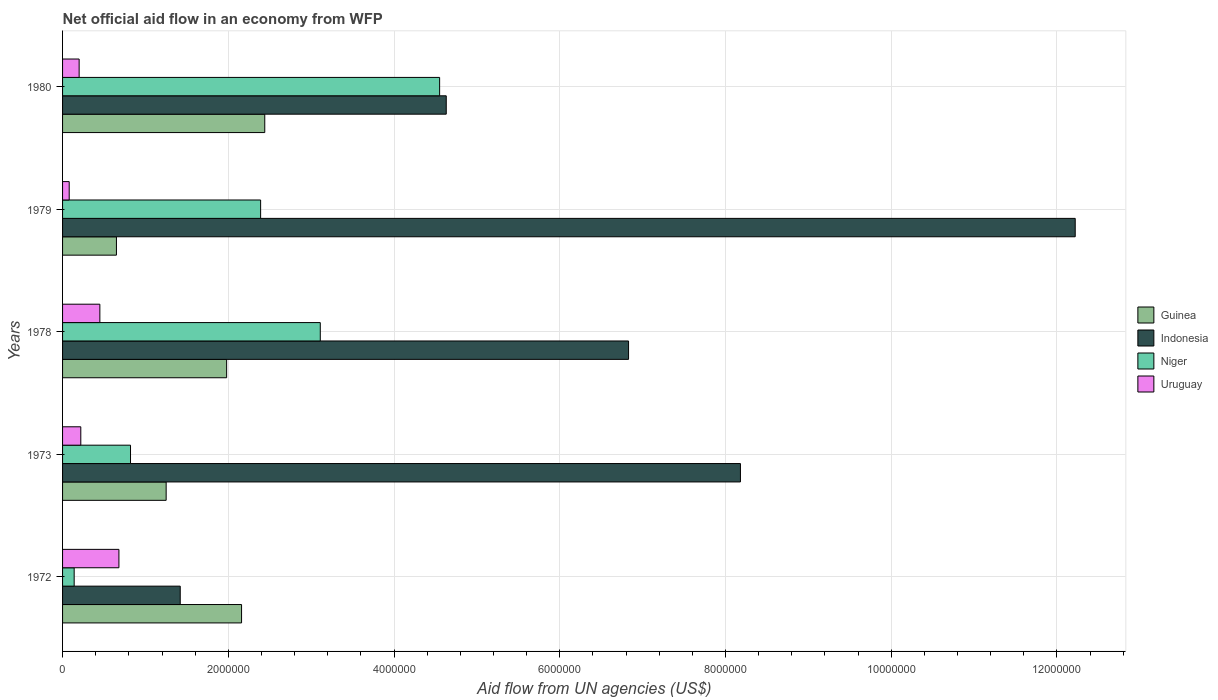How many different coloured bars are there?
Your response must be concise. 4. How many groups of bars are there?
Offer a very short reply. 5. Are the number of bars per tick equal to the number of legend labels?
Your response must be concise. Yes. Are the number of bars on each tick of the Y-axis equal?
Give a very brief answer. Yes. Across all years, what is the maximum net official aid flow in Uruguay?
Offer a very short reply. 6.80e+05. In which year was the net official aid flow in Indonesia maximum?
Make the answer very short. 1979. In which year was the net official aid flow in Uruguay minimum?
Provide a short and direct response. 1979. What is the total net official aid flow in Uruguay in the graph?
Offer a terse response. 1.63e+06. What is the difference between the net official aid flow in Indonesia in 1973 and the net official aid flow in Guinea in 1972?
Give a very brief answer. 6.02e+06. What is the average net official aid flow in Niger per year?
Your answer should be compact. 2.20e+06. In the year 1973, what is the difference between the net official aid flow in Niger and net official aid flow in Uruguay?
Ensure brevity in your answer.  6.00e+05. In how many years, is the net official aid flow in Niger greater than 400000 US$?
Give a very brief answer. 4. What is the ratio of the net official aid flow in Uruguay in 1972 to that in 1978?
Provide a short and direct response. 1.51. What does the 1st bar from the bottom in 1979 represents?
Offer a very short reply. Guinea. How many bars are there?
Provide a short and direct response. 20. What is the difference between two consecutive major ticks on the X-axis?
Provide a succinct answer. 2.00e+06. Are the values on the major ticks of X-axis written in scientific E-notation?
Your answer should be very brief. No. Does the graph contain any zero values?
Make the answer very short. No. How many legend labels are there?
Offer a very short reply. 4. What is the title of the graph?
Give a very brief answer. Net official aid flow in an economy from WFP. Does "Papua New Guinea" appear as one of the legend labels in the graph?
Your answer should be very brief. No. What is the label or title of the X-axis?
Your answer should be compact. Aid flow from UN agencies (US$). What is the label or title of the Y-axis?
Your answer should be very brief. Years. What is the Aid flow from UN agencies (US$) of Guinea in 1972?
Your response must be concise. 2.16e+06. What is the Aid flow from UN agencies (US$) in Indonesia in 1972?
Make the answer very short. 1.42e+06. What is the Aid flow from UN agencies (US$) of Niger in 1972?
Keep it short and to the point. 1.40e+05. What is the Aid flow from UN agencies (US$) in Uruguay in 1972?
Keep it short and to the point. 6.80e+05. What is the Aid flow from UN agencies (US$) of Guinea in 1973?
Give a very brief answer. 1.25e+06. What is the Aid flow from UN agencies (US$) of Indonesia in 1973?
Your answer should be very brief. 8.18e+06. What is the Aid flow from UN agencies (US$) in Niger in 1973?
Provide a succinct answer. 8.20e+05. What is the Aid flow from UN agencies (US$) of Guinea in 1978?
Your response must be concise. 1.98e+06. What is the Aid flow from UN agencies (US$) in Indonesia in 1978?
Give a very brief answer. 6.83e+06. What is the Aid flow from UN agencies (US$) of Niger in 1978?
Provide a short and direct response. 3.11e+06. What is the Aid flow from UN agencies (US$) of Uruguay in 1978?
Offer a terse response. 4.50e+05. What is the Aid flow from UN agencies (US$) of Guinea in 1979?
Keep it short and to the point. 6.50e+05. What is the Aid flow from UN agencies (US$) in Indonesia in 1979?
Your response must be concise. 1.22e+07. What is the Aid flow from UN agencies (US$) in Niger in 1979?
Make the answer very short. 2.39e+06. What is the Aid flow from UN agencies (US$) of Uruguay in 1979?
Offer a terse response. 8.00e+04. What is the Aid flow from UN agencies (US$) in Guinea in 1980?
Offer a terse response. 2.44e+06. What is the Aid flow from UN agencies (US$) in Indonesia in 1980?
Make the answer very short. 4.63e+06. What is the Aid flow from UN agencies (US$) in Niger in 1980?
Give a very brief answer. 4.55e+06. What is the Aid flow from UN agencies (US$) of Uruguay in 1980?
Keep it short and to the point. 2.00e+05. Across all years, what is the maximum Aid flow from UN agencies (US$) in Guinea?
Your response must be concise. 2.44e+06. Across all years, what is the maximum Aid flow from UN agencies (US$) in Indonesia?
Keep it short and to the point. 1.22e+07. Across all years, what is the maximum Aid flow from UN agencies (US$) in Niger?
Keep it short and to the point. 4.55e+06. Across all years, what is the maximum Aid flow from UN agencies (US$) in Uruguay?
Give a very brief answer. 6.80e+05. Across all years, what is the minimum Aid flow from UN agencies (US$) in Guinea?
Your answer should be very brief. 6.50e+05. Across all years, what is the minimum Aid flow from UN agencies (US$) of Indonesia?
Keep it short and to the point. 1.42e+06. Across all years, what is the minimum Aid flow from UN agencies (US$) in Niger?
Offer a terse response. 1.40e+05. What is the total Aid flow from UN agencies (US$) of Guinea in the graph?
Give a very brief answer. 8.48e+06. What is the total Aid flow from UN agencies (US$) in Indonesia in the graph?
Ensure brevity in your answer.  3.33e+07. What is the total Aid flow from UN agencies (US$) in Niger in the graph?
Make the answer very short. 1.10e+07. What is the total Aid flow from UN agencies (US$) of Uruguay in the graph?
Offer a terse response. 1.63e+06. What is the difference between the Aid flow from UN agencies (US$) of Guinea in 1972 and that in 1973?
Offer a very short reply. 9.10e+05. What is the difference between the Aid flow from UN agencies (US$) in Indonesia in 1972 and that in 1973?
Provide a short and direct response. -6.76e+06. What is the difference between the Aid flow from UN agencies (US$) in Niger in 1972 and that in 1973?
Keep it short and to the point. -6.80e+05. What is the difference between the Aid flow from UN agencies (US$) of Indonesia in 1972 and that in 1978?
Offer a very short reply. -5.41e+06. What is the difference between the Aid flow from UN agencies (US$) in Niger in 1972 and that in 1978?
Keep it short and to the point. -2.97e+06. What is the difference between the Aid flow from UN agencies (US$) of Guinea in 1972 and that in 1979?
Give a very brief answer. 1.51e+06. What is the difference between the Aid flow from UN agencies (US$) in Indonesia in 1972 and that in 1979?
Your response must be concise. -1.08e+07. What is the difference between the Aid flow from UN agencies (US$) of Niger in 1972 and that in 1979?
Provide a succinct answer. -2.25e+06. What is the difference between the Aid flow from UN agencies (US$) in Uruguay in 1972 and that in 1979?
Make the answer very short. 6.00e+05. What is the difference between the Aid flow from UN agencies (US$) of Guinea in 1972 and that in 1980?
Your answer should be compact. -2.80e+05. What is the difference between the Aid flow from UN agencies (US$) of Indonesia in 1972 and that in 1980?
Keep it short and to the point. -3.21e+06. What is the difference between the Aid flow from UN agencies (US$) in Niger in 1972 and that in 1980?
Your answer should be compact. -4.41e+06. What is the difference between the Aid flow from UN agencies (US$) in Guinea in 1973 and that in 1978?
Keep it short and to the point. -7.30e+05. What is the difference between the Aid flow from UN agencies (US$) of Indonesia in 1973 and that in 1978?
Make the answer very short. 1.35e+06. What is the difference between the Aid flow from UN agencies (US$) in Niger in 1973 and that in 1978?
Provide a short and direct response. -2.29e+06. What is the difference between the Aid flow from UN agencies (US$) of Uruguay in 1973 and that in 1978?
Give a very brief answer. -2.30e+05. What is the difference between the Aid flow from UN agencies (US$) of Guinea in 1973 and that in 1979?
Keep it short and to the point. 6.00e+05. What is the difference between the Aid flow from UN agencies (US$) of Indonesia in 1973 and that in 1979?
Provide a short and direct response. -4.04e+06. What is the difference between the Aid flow from UN agencies (US$) in Niger in 1973 and that in 1979?
Make the answer very short. -1.57e+06. What is the difference between the Aid flow from UN agencies (US$) of Guinea in 1973 and that in 1980?
Offer a terse response. -1.19e+06. What is the difference between the Aid flow from UN agencies (US$) in Indonesia in 1973 and that in 1980?
Your response must be concise. 3.55e+06. What is the difference between the Aid flow from UN agencies (US$) in Niger in 1973 and that in 1980?
Make the answer very short. -3.73e+06. What is the difference between the Aid flow from UN agencies (US$) in Guinea in 1978 and that in 1979?
Provide a short and direct response. 1.33e+06. What is the difference between the Aid flow from UN agencies (US$) of Indonesia in 1978 and that in 1979?
Make the answer very short. -5.39e+06. What is the difference between the Aid flow from UN agencies (US$) in Niger in 1978 and that in 1979?
Provide a short and direct response. 7.20e+05. What is the difference between the Aid flow from UN agencies (US$) of Uruguay in 1978 and that in 1979?
Your answer should be very brief. 3.70e+05. What is the difference between the Aid flow from UN agencies (US$) in Guinea in 1978 and that in 1980?
Keep it short and to the point. -4.60e+05. What is the difference between the Aid flow from UN agencies (US$) of Indonesia in 1978 and that in 1980?
Give a very brief answer. 2.20e+06. What is the difference between the Aid flow from UN agencies (US$) of Niger in 1978 and that in 1980?
Keep it short and to the point. -1.44e+06. What is the difference between the Aid flow from UN agencies (US$) in Uruguay in 1978 and that in 1980?
Keep it short and to the point. 2.50e+05. What is the difference between the Aid flow from UN agencies (US$) of Guinea in 1979 and that in 1980?
Your response must be concise. -1.79e+06. What is the difference between the Aid flow from UN agencies (US$) in Indonesia in 1979 and that in 1980?
Offer a very short reply. 7.59e+06. What is the difference between the Aid flow from UN agencies (US$) of Niger in 1979 and that in 1980?
Your answer should be compact. -2.16e+06. What is the difference between the Aid flow from UN agencies (US$) of Guinea in 1972 and the Aid flow from UN agencies (US$) of Indonesia in 1973?
Offer a terse response. -6.02e+06. What is the difference between the Aid flow from UN agencies (US$) of Guinea in 1972 and the Aid flow from UN agencies (US$) of Niger in 1973?
Make the answer very short. 1.34e+06. What is the difference between the Aid flow from UN agencies (US$) in Guinea in 1972 and the Aid flow from UN agencies (US$) in Uruguay in 1973?
Provide a short and direct response. 1.94e+06. What is the difference between the Aid flow from UN agencies (US$) of Indonesia in 1972 and the Aid flow from UN agencies (US$) of Niger in 1973?
Your answer should be compact. 6.00e+05. What is the difference between the Aid flow from UN agencies (US$) in Indonesia in 1972 and the Aid flow from UN agencies (US$) in Uruguay in 1973?
Give a very brief answer. 1.20e+06. What is the difference between the Aid flow from UN agencies (US$) in Niger in 1972 and the Aid flow from UN agencies (US$) in Uruguay in 1973?
Your answer should be very brief. -8.00e+04. What is the difference between the Aid flow from UN agencies (US$) in Guinea in 1972 and the Aid flow from UN agencies (US$) in Indonesia in 1978?
Provide a succinct answer. -4.67e+06. What is the difference between the Aid flow from UN agencies (US$) in Guinea in 1972 and the Aid flow from UN agencies (US$) in Niger in 1978?
Provide a succinct answer. -9.50e+05. What is the difference between the Aid flow from UN agencies (US$) of Guinea in 1972 and the Aid flow from UN agencies (US$) of Uruguay in 1978?
Offer a very short reply. 1.71e+06. What is the difference between the Aid flow from UN agencies (US$) of Indonesia in 1972 and the Aid flow from UN agencies (US$) of Niger in 1978?
Offer a very short reply. -1.69e+06. What is the difference between the Aid flow from UN agencies (US$) in Indonesia in 1972 and the Aid flow from UN agencies (US$) in Uruguay in 1978?
Provide a succinct answer. 9.70e+05. What is the difference between the Aid flow from UN agencies (US$) in Niger in 1972 and the Aid flow from UN agencies (US$) in Uruguay in 1978?
Provide a succinct answer. -3.10e+05. What is the difference between the Aid flow from UN agencies (US$) in Guinea in 1972 and the Aid flow from UN agencies (US$) in Indonesia in 1979?
Make the answer very short. -1.01e+07. What is the difference between the Aid flow from UN agencies (US$) in Guinea in 1972 and the Aid flow from UN agencies (US$) in Uruguay in 1979?
Provide a succinct answer. 2.08e+06. What is the difference between the Aid flow from UN agencies (US$) in Indonesia in 1972 and the Aid flow from UN agencies (US$) in Niger in 1979?
Offer a very short reply. -9.70e+05. What is the difference between the Aid flow from UN agencies (US$) in Indonesia in 1972 and the Aid flow from UN agencies (US$) in Uruguay in 1979?
Provide a short and direct response. 1.34e+06. What is the difference between the Aid flow from UN agencies (US$) of Guinea in 1972 and the Aid flow from UN agencies (US$) of Indonesia in 1980?
Your response must be concise. -2.47e+06. What is the difference between the Aid flow from UN agencies (US$) of Guinea in 1972 and the Aid flow from UN agencies (US$) of Niger in 1980?
Provide a succinct answer. -2.39e+06. What is the difference between the Aid flow from UN agencies (US$) of Guinea in 1972 and the Aid flow from UN agencies (US$) of Uruguay in 1980?
Provide a succinct answer. 1.96e+06. What is the difference between the Aid flow from UN agencies (US$) of Indonesia in 1972 and the Aid flow from UN agencies (US$) of Niger in 1980?
Offer a very short reply. -3.13e+06. What is the difference between the Aid flow from UN agencies (US$) of Indonesia in 1972 and the Aid flow from UN agencies (US$) of Uruguay in 1980?
Offer a terse response. 1.22e+06. What is the difference between the Aid flow from UN agencies (US$) in Guinea in 1973 and the Aid flow from UN agencies (US$) in Indonesia in 1978?
Offer a terse response. -5.58e+06. What is the difference between the Aid flow from UN agencies (US$) of Guinea in 1973 and the Aid flow from UN agencies (US$) of Niger in 1978?
Keep it short and to the point. -1.86e+06. What is the difference between the Aid flow from UN agencies (US$) in Indonesia in 1973 and the Aid flow from UN agencies (US$) in Niger in 1978?
Make the answer very short. 5.07e+06. What is the difference between the Aid flow from UN agencies (US$) of Indonesia in 1973 and the Aid flow from UN agencies (US$) of Uruguay in 1978?
Give a very brief answer. 7.73e+06. What is the difference between the Aid flow from UN agencies (US$) of Guinea in 1973 and the Aid flow from UN agencies (US$) of Indonesia in 1979?
Give a very brief answer. -1.10e+07. What is the difference between the Aid flow from UN agencies (US$) of Guinea in 1973 and the Aid flow from UN agencies (US$) of Niger in 1979?
Provide a short and direct response. -1.14e+06. What is the difference between the Aid flow from UN agencies (US$) of Guinea in 1973 and the Aid flow from UN agencies (US$) of Uruguay in 1979?
Give a very brief answer. 1.17e+06. What is the difference between the Aid flow from UN agencies (US$) of Indonesia in 1973 and the Aid flow from UN agencies (US$) of Niger in 1979?
Provide a short and direct response. 5.79e+06. What is the difference between the Aid flow from UN agencies (US$) of Indonesia in 1973 and the Aid flow from UN agencies (US$) of Uruguay in 1979?
Give a very brief answer. 8.10e+06. What is the difference between the Aid flow from UN agencies (US$) of Niger in 1973 and the Aid flow from UN agencies (US$) of Uruguay in 1979?
Your answer should be compact. 7.40e+05. What is the difference between the Aid flow from UN agencies (US$) in Guinea in 1973 and the Aid flow from UN agencies (US$) in Indonesia in 1980?
Your answer should be very brief. -3.38e+06. What is the difference between the Aid flow from UN agencies (US$) of Guinea in 1973 and the Aid flow from UN agencies (US$) of Niger in 1980?
Offer a terse response. -3.30e+06. What is the difference between the Aid flow from UN agencies (US$) in Guinea in 1973 and the Aid flow from UN agencies (US$) in Uruguay in 1980?
Give a very brief answer. 1.05e+06. What is the difference between the Aid flow from UN agencies (US$) in Indonesia in 1973 and the Aid flow from UN agencies (US$) in Niger in 1980?
Your answer should be compact. 3.63e+06. What is the difference between the Aid flow from UN agencies (US$) in Indonesia in 1973 and the Aid flow from UN agencies (US$) in Uruguay in 1980?
Make the answer very short. 7.98e+06. What is the difference between the Aid flow from UN agencies (US$) in Niger in 1973 and the Aid flow from UN agencies (US$) in Uruguay in 1980?
Your response must be concise. 6.20e+05. What is the difference between the Aid flow from UN agencies (US$) in Guinea in 1978 and the Aid flow from UN agencies (US$) in Indonesia in 1979?
Provide a succinct answer. -1.02e+07. What is the difference between the Aid flow from UN agencies (US$) in Guinea in 1978 and the Aid flow from UN agencies (US$) in Niger in 1979?
Offer a very short reply. -4.10e+05. What is the difference between the Aid flow from UN agencies (US$) in Guinea in 1978 and the Aid flow from UN agencies (US$) in Uruguay in 1979?
Keep it short and to the point. 1.90e+06. What is the difference between the Aid flow from UN agencies (US$) of Indonesia in 1978 and the Aid flow from UN agencies (US$) of Niger in 1979?
Give a very brief answer. 4.44e+06. What is the difference between the Aid flow from UN agencies (US$) of Indonesia in 1978 and the Aid flow from UN agencies (US$) of Uruguay in 1979?
Keep it short and to the point. 6.75e+06. What is the difference between the Aid flow from UN agencies (US$) of Niger in 1978 and the Aid flow from UN agencies (US$) of Uruguay in 1979?
Your answer should be compact. 3.03e+06. What is the difference between the Aid flow from UN agencies (US$) in Guinea in 1978 and the Aid flow from UN agencies (US$) in Indonesia in 1980?
Provide a short and direct response. -2.65e+06. What is the difference between the Aid flow from UN agencies (US$) in Guinea in 1978 and the Aid flow from UN agencies (US$) in Niger in 1980?
Your response must be concise. -2.57e+06. What is the difference between the Aid flow from UN agencies (US$) of Guinea in 1978 and the Aid flow from UN agencies (US$) of Uruguay in 1980?
Offer a very short reply. 1.78e+06. What is the difference between the Aid flow from UN agencies (US$) of Indonesia in 1978 and the Aid flow from UN agencies (US$) of Niger in 1980?
Keep it short and to the point. 2.28e+06. What is the difference between the Aid flow from UN agencies (US$) in Indonesia in 1978 and the Aid flow from UN agencies (US$) in Uruguay in 1980?
Provide a short and direct response. 6.63e+06. What is the difference between the Aid flow from UN agencies (US$) of Niger in 1978 and the Aid flow from UN agencies (US$) of Uruguay in 1980?
Your answer should be compact. 2.91e+06. What is the difference between the Aid flow from UN agencies (US$) in Guinea in 1979 and the Aid flow from UN agencies (US$) in Indonesia in 1980?
Offer a very short reply. -3.98e+06. What is the difference between the Aid flow from UN agencies (US$) of Guinea in 1979 and the Aid flow from UN agencies (US$) of Niger in 1980?
Offer a terse response. -3.90e+06. What is the difference between the Aid flow from UN agencies (US$) of Guinea in 1979 and the Aid flow from UN agencies (US$) of Uruguay in 1980?
Ensure brevity in your answer.  4.50e+05. What is the difference between the Aid flow from UN agencies (US$) of Indonesia in 1979 and the Aid flow from UN agencies (US$) of Niger in 1980?
Provide a short and direct response. 7.67e+06. What is the difference between the Aid flow from UN agencies (US$) in Indonesia in 1979 and the Aid flow from UN agencies (US$) in Uruguay in 1980?
Offer a terse response. 1.20e+07. What is the difference between the Aid flow from UN agencies (US$) of Niger in 1979 and the Aid flow from UN agencies (US$) of Uruguay in 1980?
Your answer should be compact. 2.19e+06. What is the average Aid flow from UN agencies (US$) of Guinea per year?
Make the answer very short. 1.70e+06. What is the average Aid flow from UN agencies (US$) in Indonesia per year?
Give a very brief answer. 6.66e+06. What is the average Aid flow from UN agencies (US$) of Niger per year?
Your answer should be compact. 2.20e+06. What is the average Aid flow from UN agencies (US$) of Uruguay per year?
Offer a very short reply. 3.26e+05. In the year 1972, what is the difference between the Aid flow from UN agencies (US$) of Guinea and Aid flow from UN agencies (US$) of Indonesia?
Keep it short and to the point. 7.40e+05. In the year 1972, what is the difference between the Aid flow from UN agencies (US$) in Guinea and Aid flow from UN agencies (US$) in Niger?
Keep it short and to the point. 2.02e+06. In the year 1972, what is the difference between the Aid flow from UN agencies (US$) in Guinea and Aid flow from UN agencies (US$) in Uruguay?
Make the answer very short. 1.48e+06. In the year 1972, what is the difference between the Aid flow from UN agencies (US$) of Indonesia and Aid flow from UN agencies (US$) of Niger?
Offer a very short reply. 1.28e+06. In the year 1972, what is the difference between the Aid flow from UN agencies (US$) of Indonesia and Aid flow from UN agencies (US$) of Uruguay?
Give a very brief answer. 7.40e+05. In the year 1972, what is the difference between the Aid flow from UN agencies (US$) in Niger and Aid flow from UN agencies (US$) in Uruguay?
Your answer should be compact. -5.40e+05. In the year 1973, what is the difference between the Aid flow from UN agencies (US$) in Guinea and Aid flow from UN agencies (US$) in Indonesia?
Provide a succinct answer. -6.93e+06. In the year 1973, what is the difference between the Aid flow from UN agencies (US$) of Guinea and Aid flow from UN agencies (US$) of Uruguay?
Offer a terse response. 1.03e+06. In the year 1973, what is the difference between the Aid flow from UN agencies (US$) in Indonesia and Aid flow from UN agencies (US$) in Niger?
Offer a terse response. 7.36e+06. In the year 1973, what is the difference between the Aid flow from UN agencies (US$) of Indonesia and Aid flow from UN agencies (US$) of Uruguay?
Keep it short and to the point. 7.96e+06. In the year 1978, what is the difference between the Aid flow from UN agencies (US$) in Guinea and Aid flow from UN agencies (US$) in Indonesia?
Your answer should be compact. -4.85e+06. In the year 1978, what is the difference between the Aid flow from UN agencies (US$) of Guinea and Aid flow from UN agencies (US$) of Niger?
Offer a very short reply. -1.13e+06. In the year 1978, what is the difference between the Aid flow from UN agencies (US$) of Guinea and Aid flow from UN agencies (US$) of Uruguay?
Ensure brevity in your answer.  1.53e+06. In the year 1978, what is the difference between the Aid flow from UN agencies (US$) in Indonesia and Aid flow from UN agencies (US$) in Niger?
Make the answer very short. 3.72e+06. In the year 1978, what is the difference between the Aid flow from UN agencies (US$) in Indonesia and Aid flow from UN agencies (US$) in Uruguay?
Your answer should be very brief. 6.38e+06. In the year 1978, what is the difference between the Aid flow from UN agencies (US$) in Niger and Aid flow from UN agencies (US$) in Uruguay?
Ensure brevity in your answer.  2.66e+06. In the year 1979, what is the difference between the Aid flow from UN agencies (US$) of Guinea and Aid flow from UN agencies (US$) of Indonesia?
Provide a succinct answer. -1.16e+07. In the year 1979, what is the difference between the Aid flow from UN agencies (US$) in Guinea and Aid flow from UN agencies (US$) in Niger?
Keep it short and to the point. -1.74e+06. In the year 1979, what is the difference between the Aid flow from UN agencies (US$) of Guinea and Aid flow from UN agencies (US$) of Uruguay?
Your answer should be compact. 5.70e+05. In the year 1979, what is the difference between the Aid flow from UN agencies (US$) in Indonesia and Aid flow from UN agencies (US$) in Niger?
Your response must be concise. 9.83e+06. In the year 1979, what is the difference between the Aid flow from UN agencies (US$) of Indonesia and Aid flow from UN agencies (US$) of Uruguay?
Provide a succinct answer. 1.21e+07. In the year 1979, what is the difference between the Aid flow from UN agencies (US$) in Niger and Aid flow from UN agencies (US$) in Uruguay?
Provide a short and direct response. 2.31e+06. In the year 1980, what is the difference between the Aid flow from UN agencies (US$) in Guinea and Aid flow from UN agencies (US$) in Indonesia?
Offer a terse response. -2.19e+06. In the year 1980, what is the difference between the Aid flow from UN agencies (US$) in Guinea and Aid flow from UN agencies (US$) in Niger?
Provide a short and direct response. -2.11e+06. In the year 1980, what is the difference between the Aid flow from UN agencies (US$) in Guinea and Aid flow from UN agencies (US$) in Uruguay?
Provide a succinct answer. 2.24e+06. In the year 1980, what is the difference between the Aid flow from UN agencies (US$) of Indonesia and Aid flow from UN agencies (US$) of Niger?
Provide a succinct answer. 8.00e+04. In the year 1980, what is the difference between the Aid flow from UN agencies (US$) of Indonesia and Aid flow from UN agencies (US$) of Uruguay?
Provide a short and direct response. 4.43e+06. In the year 1980, what is the difference between the Aid flow from UN agencies (US$) in Niger and Aid flow from UN agencies (US$) in Uruguay?
Provide a succinct answer. 4.35e+06. What is the ratio of the Aid flow from UN agencies (US$) in Guinea in 1972 to that in 1973?
Your answer should be compact. 1.73. What is the ratio of the Aid flow from UN agencies (US$) of Indonesia in 1972 to that in 1973?
Your response must be concise. 0.17. What is the ratio of the Aid flow from UN agencies (US$) of Niger in 1972 to that in 1973?
Your response must be concise. 0.17. What is the ratio of the Aid flow from UN agencies (US$) of Uruguay in 1972 to that in 1973?
Make the answer very short. 3.09. What is the ratio of the Aid flow from UN agencies (US$) of Guinea in 1972 to that in 1978?
Your response must be concise. 1.09. What is the ratio of the Aid flow from UN agencies (US$) of Indonesia in 1972 to that in 1978?
Offer a very short reply. 0.21. What is the ratio of the Aid flow from UN agencies (US$) of Niger in 1972 to that in 1978?
Your answer should be very brief. 0.04. What is the ratio of the Aid flow from UN agencies (US$) of Uruguay in 1972 to that in 1978?
Offer a terse response. 1.51. What is the ratio of the Aid flow from UN agencies (US$) of Guinea in 1972 to that in 1979?
Give a very brief answer. 3.32. What is the ratio of the Aid flow from UN agencies (US$) in Indonesia in 1972 to that in 1979?
Provide a short and direct response. 0.12. What is the ratio of the Aid flow from UN agencies (US$) in Niger in 1972 to that in 1979?
Provide a short and direct response. 0.06. What is the ratio of the Aid flow from UN agencies (US$) in Guinea in 1972 to that in 1980?
Provide a succinct answer. 0.89. What is the ratio of the Aid flow from UN agencies (US$) in Indonesia in 1972 to that in 1980?
Provide a short and direct response. 0.31. What is the ratio of the Aid flow from UN agencies (US$) of Niger in 1972 to that in 1980?
Provide a succinct answer. 0.03. What is the ratio of the Aid flow from UN agencies (US$) of Uruguay in 1972 to that in 1980?
Your answer should be compact. 3.4. What is the ratio of the Aid flow from UN agencies (US$) in Guinea in 1973 to that in 1978?
Keep it short and to the point. 0.63. What is the ratio of the Aid flow from UN agencies (US$) of Indonesia in 1973 to that in 1978?
Ensure brevity in your answer.  1.2. What is the ratio of the Aid flow from UN agencies (US$) in Niger in 1973 to that in 1978?
Your answer should be compact. 0.26. What is the ratio of the Aid flow from UN agencies (US$) in Uruguay in 1973 to that in 1978?
Your answer should be very brief. 0.49. What is the ratio of the Aid flow from UN agencies (US$) of Guinea in 1973 to that in 1979?
Offer a very short reply. 1.92. What is the ratio of the Aid flow from UN agencies (US$) of Indonesia in 1973 to that in 1979?
Offer a terse response. 0.67. What is the ratio of the Aid flow from UN agencies (US$) of Niger in 1973 to that in 1979?
Your answer should be compact. 0.34. What is the ratio of the Aid flow from UN agencies (US$) in Uruguay in 1973 to that in 1979?
Make the answer very short. 2.75. What is the ratio of the Aid flow from UN agencies (US$) of Guinea in 1973 to that in 1980?
Offer a terse response. 0.51. What is the ratio of the Aid flow from UN agencies (US$) of Indonesia in 1973 to that in 1980?
Provide a short and direct response. 1.77. What is the ratio of the Aid flow from UN agencies (US$) in Niger in 1973 to that in 1980?
Provide a succinct answer. 0.18. What is the ratio of the Aid flow from UN agencies (US$) of Guinea in 1978 to that in 1979?
Provide a succinct answer. 3.05. What is the ratio of the Aid flow from UN agencies (US$) of Indonesia in 1978 to that in 1979?
Your answer should be very brief. 0.56. What is the ratio of the Aid flow from UN agencies (US$) in Niger in 1978 to that in 1979?
Make the answer very short. 1.3. What is the ratio of the Aid flow from UN agencies (US$) of Uruguay in 1978 to that in 1979?
Your answer should be compact. 5.62. What is the ratio of the Aid flow from UN agencies (US$) of Guinea in 1978 to that in 1980?
Give a very brief answer. 0.81. What is the ratio of the Aid flow from UN agencies (US$) in Indonesia in 1978 to that in 1980?
Offer a very short reply. 1.48. What is the ratio of the Aid flow from UN agencies (US$) of Niger in 1978 to that in 1980?
Offer a very short reply. 0.68. What is the ratio of the Aid flow from UN agencies (US$) of Uruguay in 1978 to that in 1980?
Give a very brief answer. 2.25. What is the ratio of the Aid flow from UN agencies (US$) in Guinea in 1979 to that in 1980?
Your response must be concise. 0.27. What is the ratio of the Aid flow from UN agencies (US$) in Indonesia in 1979 to that in 1980?
Provide a short and direct response. 2.64. What is the ratio of the Aid flow from UN agencies (US$) in Niger in 1979 to that in 1980?
Your answer should be compact. 0.53. What is the ratio of the Aid flow from UN agencies (US$) of Uruguay in 1979 to that in 1980?
Your response must be concise. 0.4. What is the difference between the highest and the second highest Aid flow from UN agencies (US$) of Guinea?
Your answer should be compact. 2.80e+05. What is the difference between the highest and the second highest Aid flow from UN agencies (US$) of Indonesia?
Your answer should be very brief. 4.04e+06. What is the difference between the highest and the second highest Aid flow from UN agencies (US$) of Niger?
Keep it short and to the point. 1.44e+06. What is the difference between the highest and the second highest Aid flow from UN agencies (US$) in Uruguay?
Your answer should be compact. 2.30e+05. What is the difference between the highest and the lowest Aid flow from UN agencies (US$) in Guinea?
Give a very brief answer. 1.79e+06. What is the difference between the highest and the lowest Aid flow from UN agencies (US$) in Indonesia?
Your response must be concise. 1.08e+07. What is the difference between the highest and the lowest Aid flow from UN agencies (US$) of Niger?
Provide a succinct answer. 4.41e+06. What is the difference between the highest and the lowest Aid flow from UN agencies (US$) of Uruguay?
Give a very brief answer. 6.00e+05. 